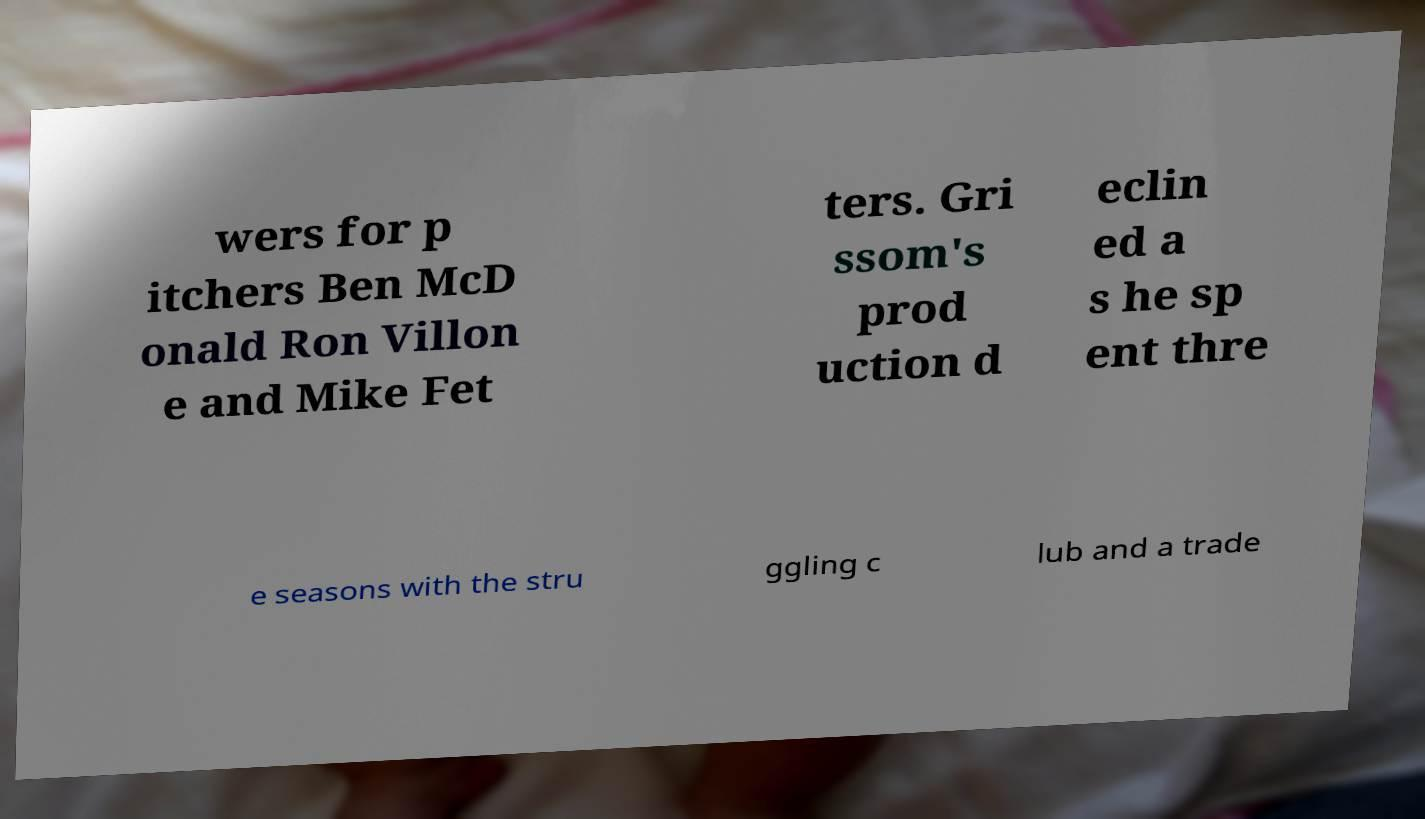Could you assist in decoding the text presented in this image and type it out clearly? wers for p itchers Ben McD onald Ron Villon e and Mike Fet ters. Gri ssom's prod uction d eclin ed a s he sp ent thre e seasons with the stru ggling c lub and a trade 